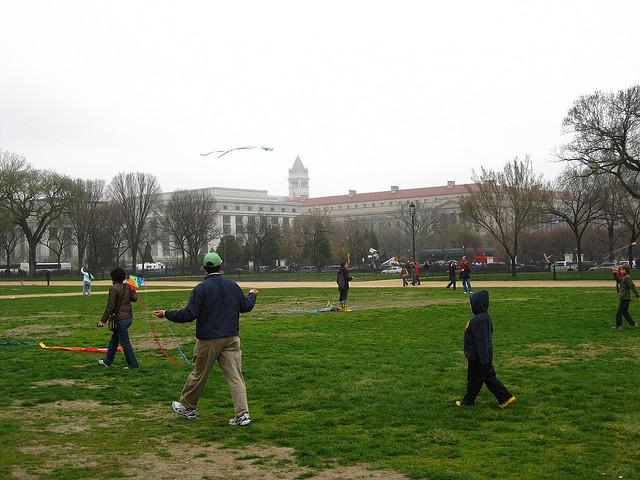What are these people doing?
Write a very short answer. Flying kites. Could these people be in a park?
Keep it brief. Yes. Is it a sunny day?
Give a very brief answer. No. Is the sky overcast?
Write a very short answer. Yes. Is this during the summer?
Short answer required. No. 